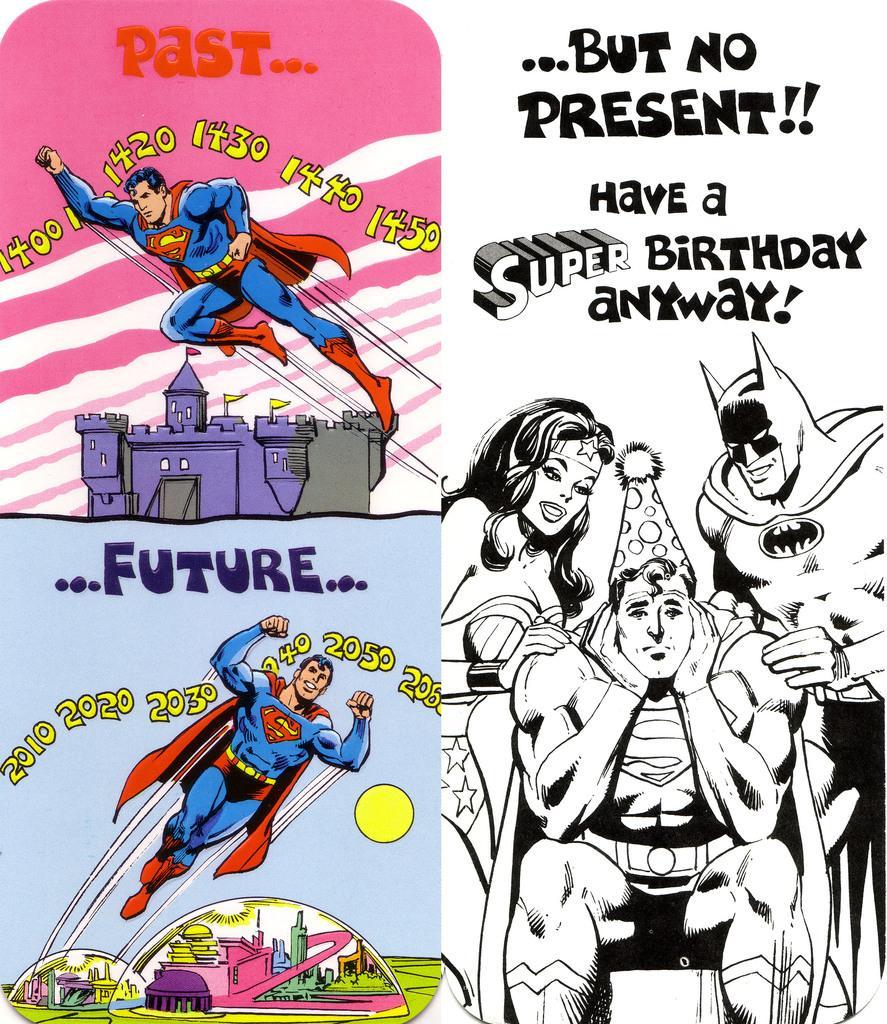Please provide a concise description of this image. This might be a poster, in this image there are some people, text, buildings. And on the right side there is a white background, and on the left side there are buildings and some text. 